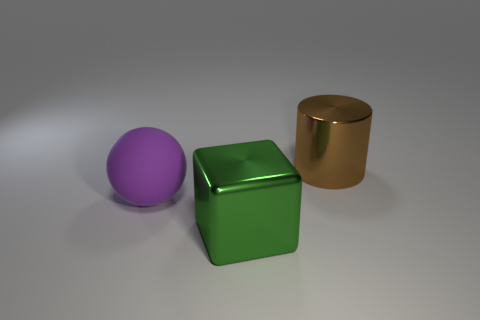Add 2 large purple rubber balls. How many objects exist? 5 Subtract all cylinders. How many objects are left? 2 Subtract 1 blocks. How many blocks are left? 0 Subtract all large green rubber cylinders. Subtract all large brown metallic cylinders. How many objects are left? 2 Add 1 purple matte balls. How many purple matte balls are left? 2 Add 3 small matte cylinders. How many small matte cylinders exist? 3 Subtract 0 green cylinders. How many objects are left? 3 Subtract all cyan cylinders. Subtract all yellow spheres. How many cylinders are left? 1 